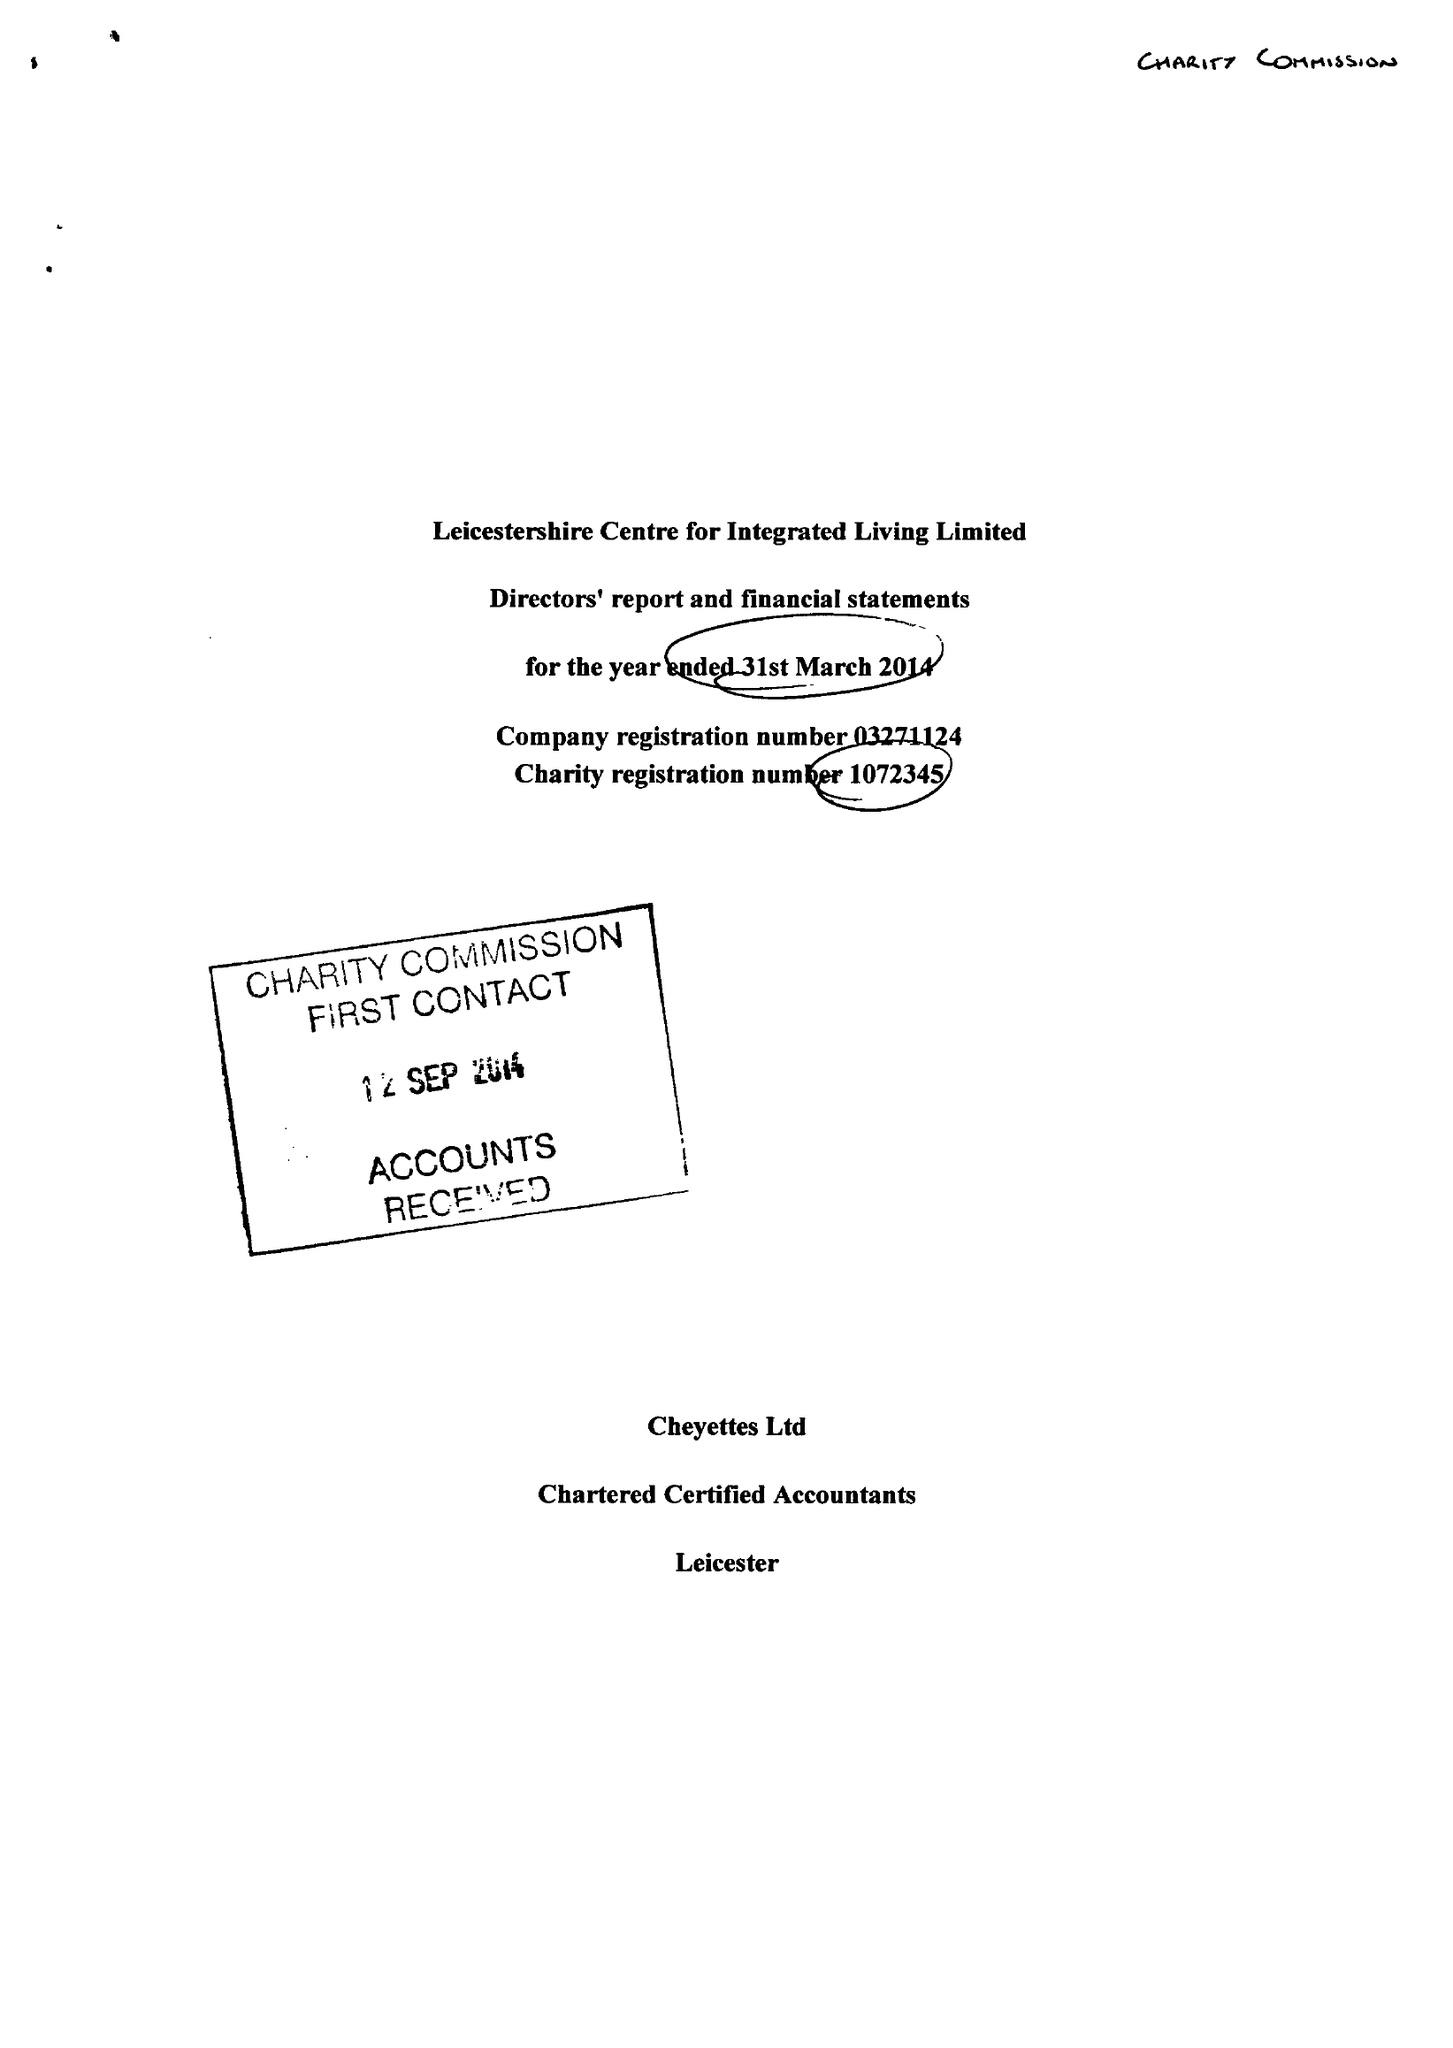What is the value for the income_annually_in_british_pounds?
Answer the question using a single word or phrase. 199983.00 